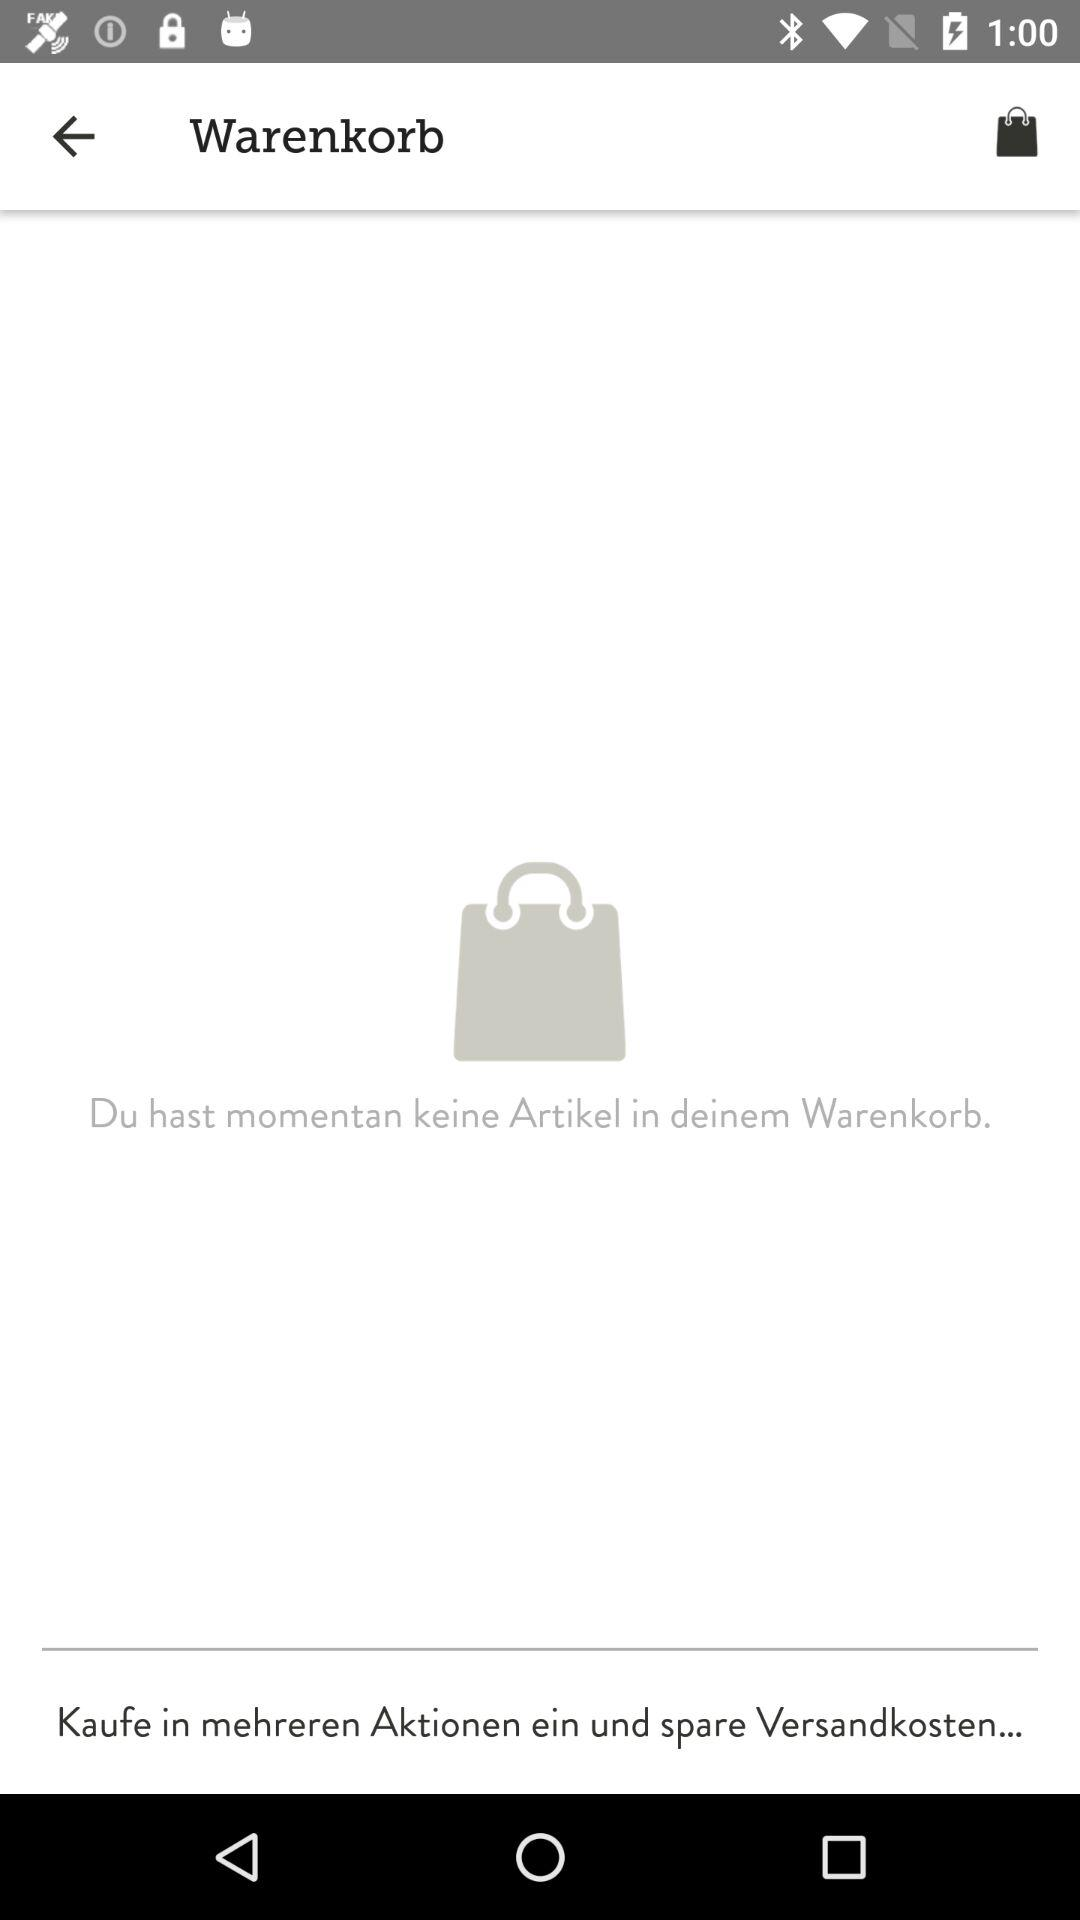How many items are in the cart?
Answer the question using a single word or phrase. 0 